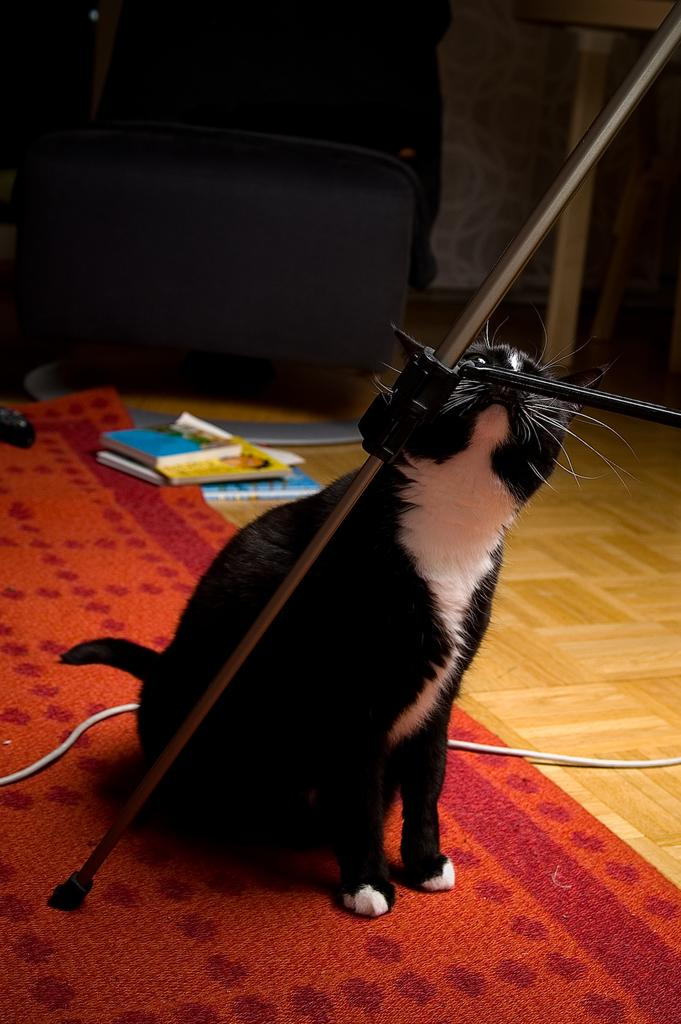What type of animal is in the image? There is a black and white cat in the image. What object can be seen near the cat? There is a stick in the image. What type of surface is visible in the image? There is a carpet in the image. What type of utility is present in the image? There is a cable wire in the image. What type of surface is beneath the carpet? There is a floor in the image. What type of item can be seen in the image? There are books in the image. What is the unidentified object in the image? There is an object in the image. What type of stocking is the cat wearing in the image? There is no stocking visible on the cat in the image. What note is the cat playing on the stick in the image? There is no note or musical instrument present in the image. 